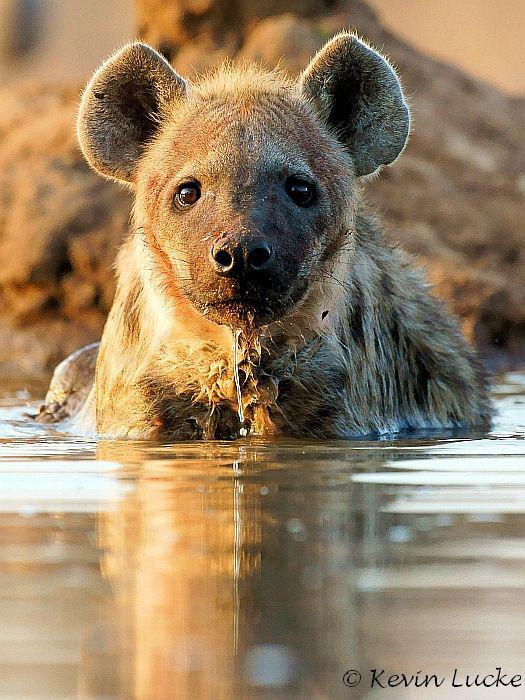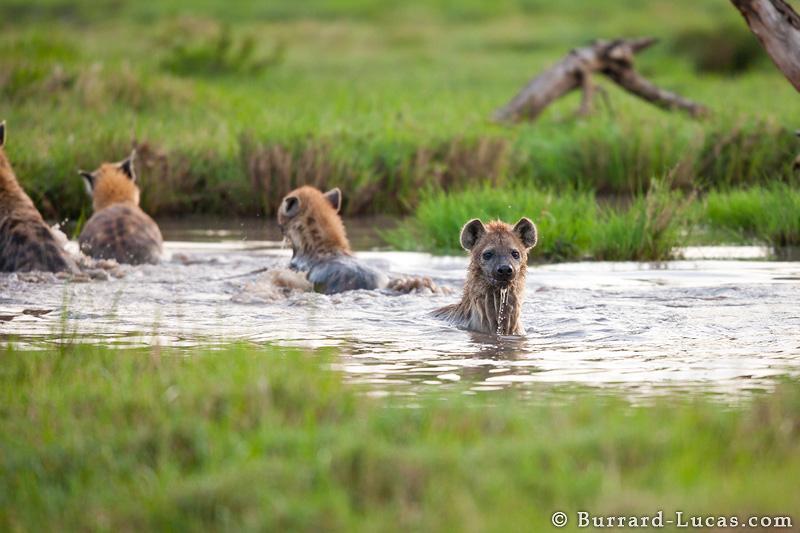The first image is the image on the left, the second image is the image on the right. Evaluate the accuracy of this statement regarding the images: "The right image contains exactly one hyena wading through a body of water.". Is it true? Answer yes or no. No. The first image is the image on the left, the second image is the image on the right. Examine the images to the left and right. Is the description "An image shows at least three hyenas in the water." accurate? Answer yes or no. Yes. The first image is the image on the left, the second image is the image on the right. For the images shown, is this caption "There are at least two hyenas in the water in the image on the right." true? Answer yes or no. Yes. The first image is the image on the left, the second image is the image on the right. Given the left and right images, does the statement "All hyenas are in the water, and one image shows a single hyena, with its head facing the camera." hold true? Answer yes or no. Yes. 